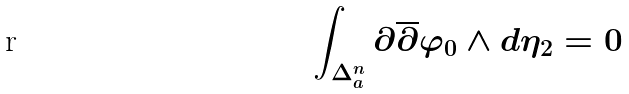Convert formula to latex. <formula><loc_0><loc_0><loc_500><loc_500>\int _ { \Delta ^ { n } _ { a } } \partial \overline { \partial } \varphi _ { 0 } \wedge d \eta _ { 2 } = 0</formula> 